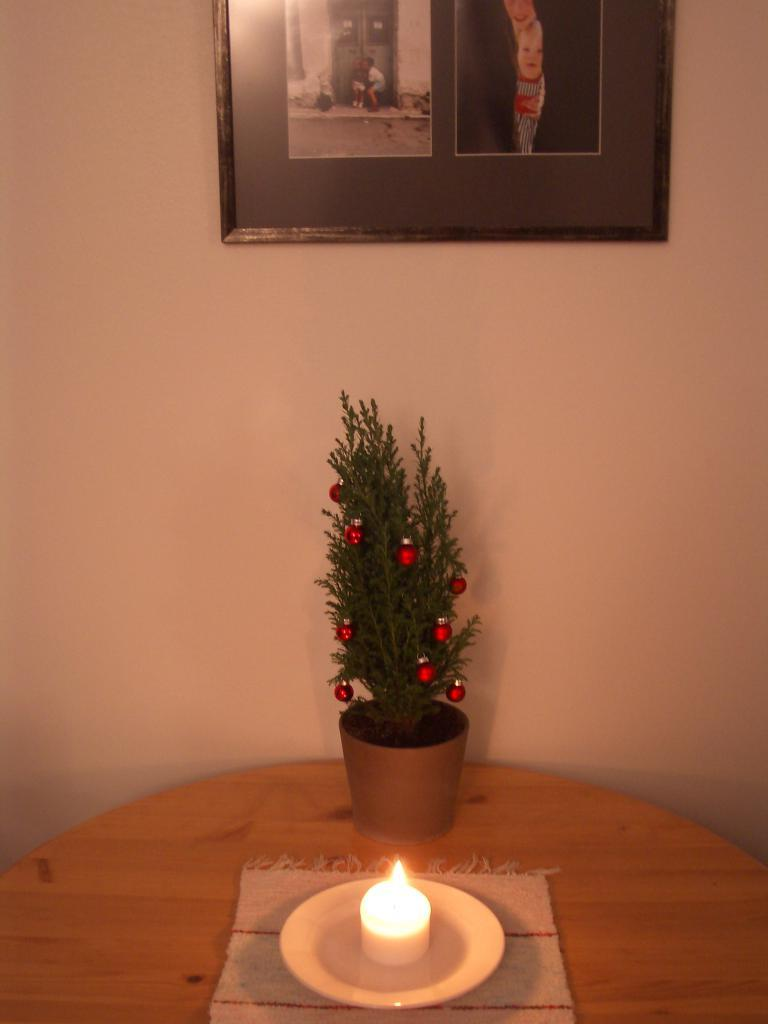What is on the table in the image? There is a plant, a candle, a plate, and a cloth on the table in the image. What else can be seen in the image besides the table? There is a photo on the wall in the image. What type of lunch is being served on the plate in the image? There is no lunch visible on the plate in the image; it is empty. 